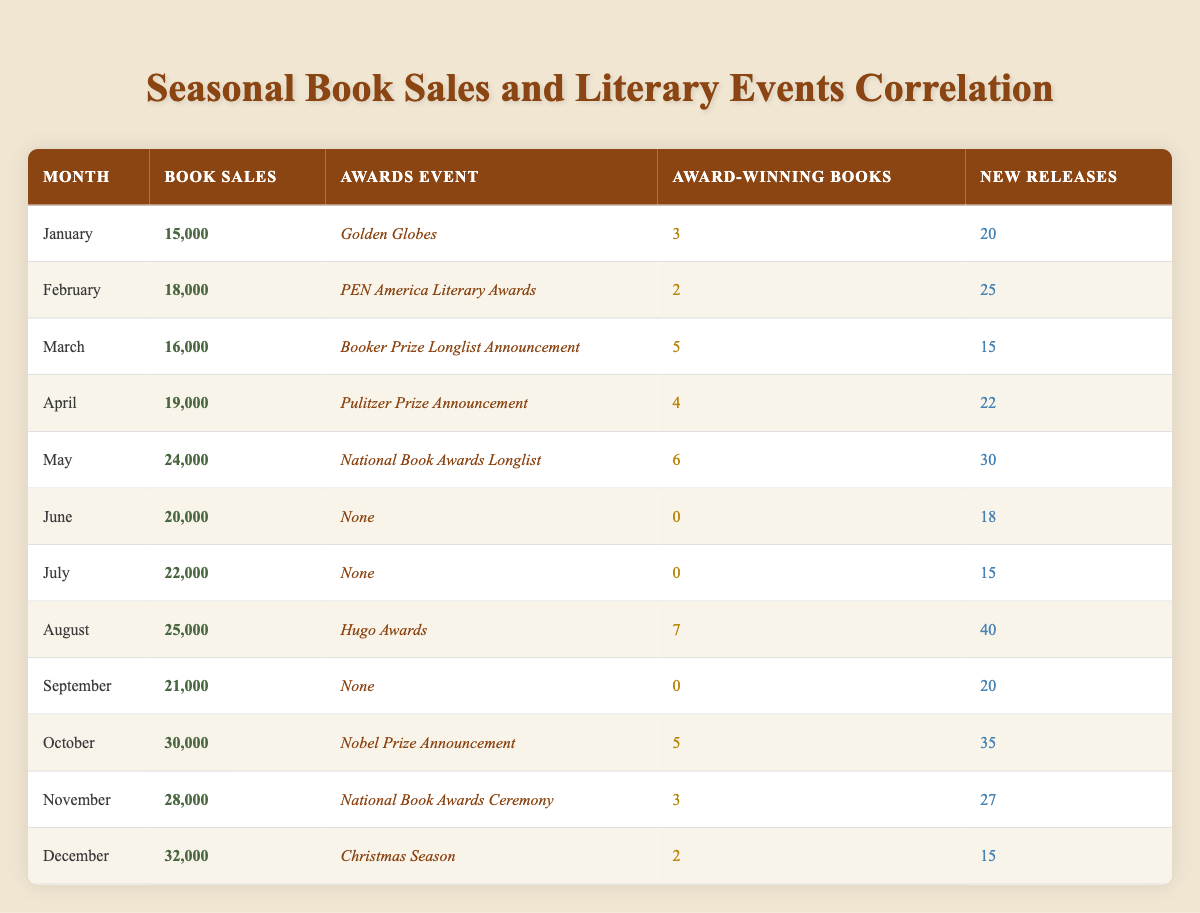What are the book sales in May? Referring to the table, the book sales in May are listed as 24,000.
Answer: 24,000 How many new releases were there in December? In December, the table indicates there were 15 new releases.
Answer: 15 Which month had the highest book sales, and what were those sales? Looking through the table, October has the highest book sales at 30,000.
Answer: October, 30,000 What is the total number of award-winning books from January to April? The award-winning books for January (3), February (2), March (5), and April (4) sum up to 3 + 2 + 5 + 4 = 14.
Answer: 14 In which months were there no awards events noted? The table shows that June, July, September had no awards events noted.
Answer: June, July, September Was there a correlation between the number of new releases and book sales in August? In August, there were 40 new releases with 25,000 book sales. We establish that while more new releases generally lead to more sales, we can't conclusively say there is a direct correlation without broader analysis.
Answer: No definitive correlation What is the average book sales for the months that had award events? The months with awards events are January (15,000), February (18,000), March (16,000), April (19,000), May (24,000), August (25,000), October (30,000), November (28,000), and December (32,000). Summing these gives 15,000 + 18,000 + 16,000 + 19,000 + 24,000 + 25,000 + 30,000 + 28,000 + 32,000 =  207,000. There are 9 months, so the average is 207,000 / 9 = 23,000.
Answer: 23,000 Which month had the highest number of new releases, and how many were there? Referring to the table, August had the highest number of new releases, totaling 40.
Answer: August, 40 Did the presence of an awards event correlate with book sales in November? In November, the National Book Awards Ceremony took place, and the book sales were 28,000. Since it is common for award events to lead to increased sales, this indicates some level of correlation. However, a more comprehensive analysis would be needed for conclusive evidence.
Answer: Yes, indicates a correlation 